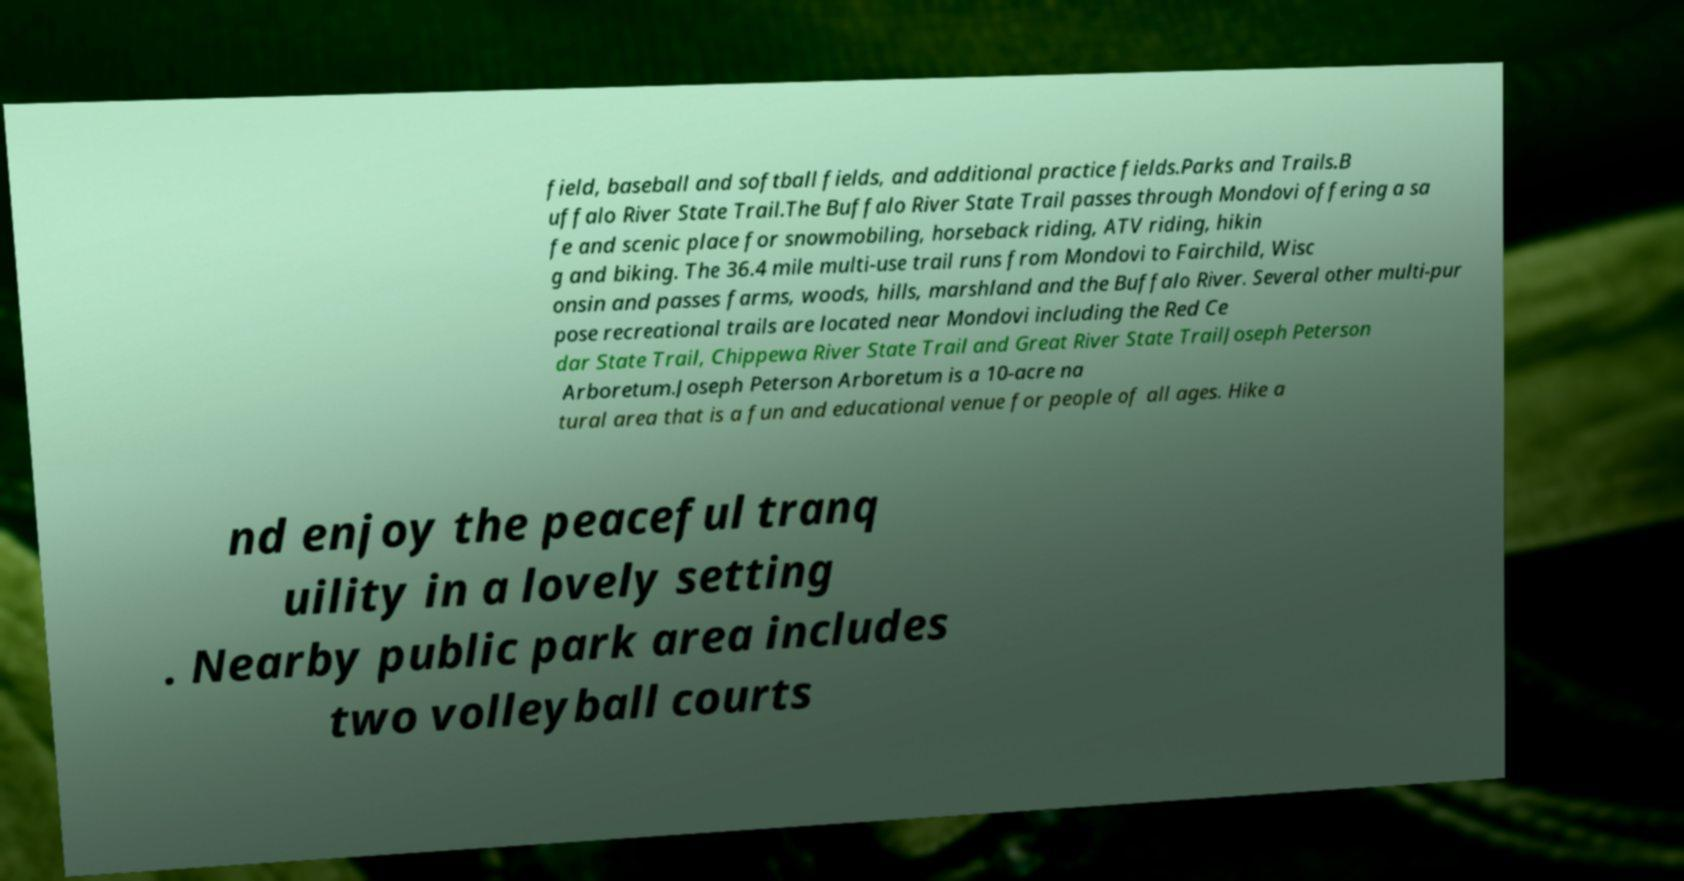Please read and relay the text visible in this image. What does it say? field, baseball and softball fields, and additional practice fields.Parks and Trails.B uffalo River State Trail.The Buffalo River State Trail passes through Mondovi offering a sa fe and scenic place for snowmobiling, horseback riding, ATV riding, hikin g and biking. The 36.4 mile multi-use trail runs from Mondovi to Fairchild, Wisc onsin and passes farms, woods, hills, marshland and the Buffalo River. Several other multi-pur pose recreational trails are located near Mondovi including the Red Ce dar State Trail, Chippewa River State Trail and Great River State TrailJoseph Peterson Arboretum.Joseph Peterson Arboretum is a 10-acre na tural area that is a fun and educational venue for people of all ages. Hike a nd enjoy the peaceful tranq uility in a lovely setting . Nearby public park area includes two volleyball courts 